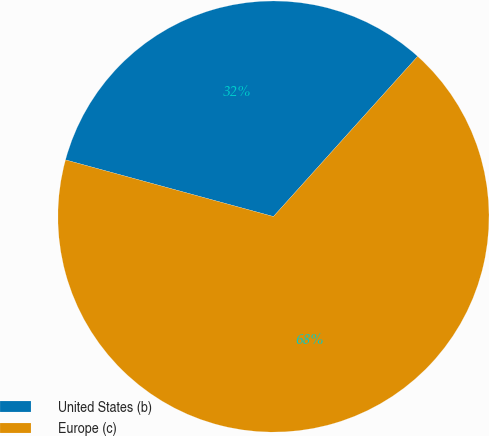Convert chart. <chart><loc_0><loc_0><loc_500><loc_500><pie_chart><fcel>United States (b)<fcel>Europe (c)<nl><fcel>32.43%<fcel>67.57%<nl></chart> 